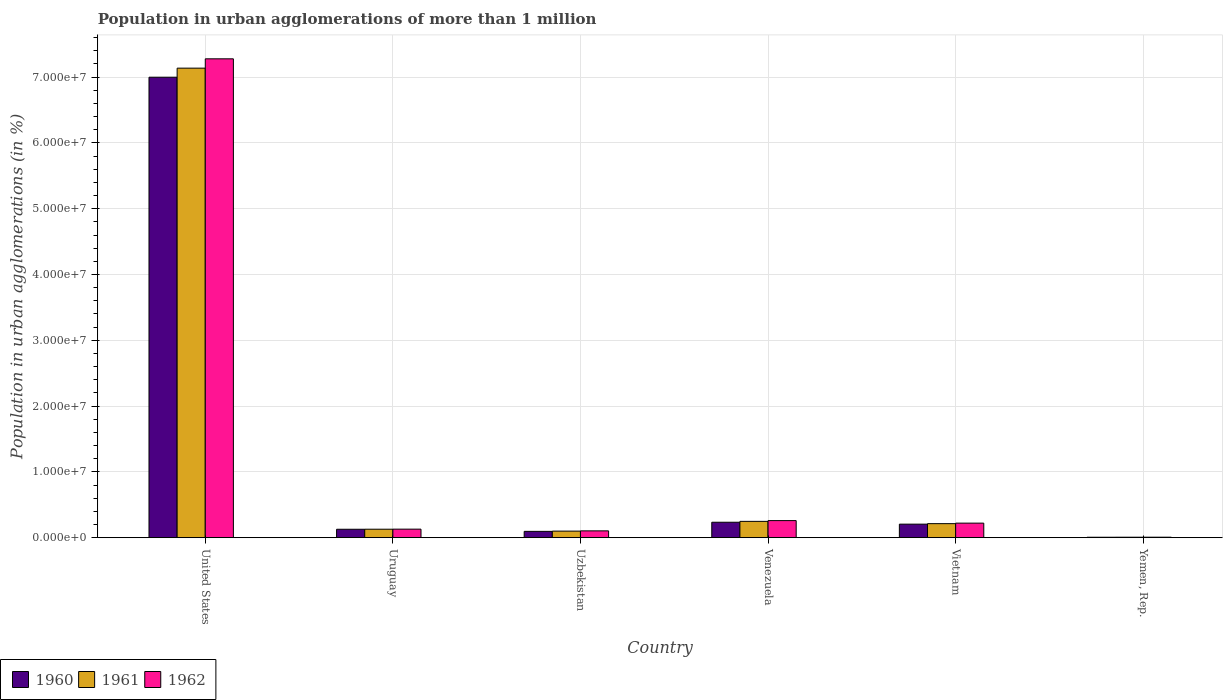Are the number of bars per tick equal to the number of legend labels?
Provide a succinct answer. Yes. How many bars are there on the 1st tick from the left?
Offer a very short reply. 3. What is the label of the 6th group of bars from the left?
Provide a short and direct response. Yemen, Rep. What is the population in urban agglomerations in 1961 in Uzbekistan?
Your response must be concise. 1.00e+06. Across all countries, what is the maximum population in urban agglomerations in 1962?
Make the answer very short. 7.28e+07. Across all countries, what is the minimum population in urban agglomerations in 1960?
Provide a short and direct response. 7.20e+04. In which country was the population in urban agglomerations in 1960 minimum?
Keep it short and to the point. Yemen, Rep. What is the total population in urban agglomerations in 1960 in the graph?
Your answer should be very brief. 7.67e+07. What is the difference between the population in urban agglomerations in 1960 in United States and that in Uzbekistan?
Offer a very short reply. 6.90e+07. What is the difference between the population in urban agglomerations in 1962 in Venezuela and the population in urban agglomerations in 1961 in United States?
Your response must be concise. -6.88e+07. What is the average population in urban agglomerations in 1960 per country?
Keep it short and to the point. 1.28e+07. What is the difference between the population in urban agglomerations of/in 1960 and population in urban agglomerations of/in 1961 in Uzbekistan?
Give a very brief answer. -3.73e+04. In how many countries, is the population in urban agglomerations in 1960 greater than 8000000 %?
Make the answer very short. 1. What is the ratio of the population in urban agglomerations in 1961 in United States to that in Venezuela?
Provide a succinct answer. 28.73. What is the difference between the highest and the second highest population in urban agglomerations in 1962?
Ensure brevity in your answer.  7.02e+07. What is the difference between the highest and the lowest population in urban agglomerations in 1961?
Your response must be concise. 7.13e+07. Is the sum of the population in urban agglomerations in 1962 in Uzbekistan and Vietnam greater than the maximum population in urban agglomerations in 1960 across all countries?
Provide a short and direct response. No. What does the 3rd bar from the left in Yemen, Rep. represents?
Ensure brevity in your answer.  1962. Is it the case that in every country, the sum of the population in urban agglomerations in 1962 and population in urban agglomerations in 1961 is greater than the population in urban agglomerations in 1960?
Ensure brevity in your answer.  Yes. How many countries are there in the graph?
Offer a terse response. 6. Are the values on the major ticks of Y-axis written in scientific E-notation?
Ensure brevity in your answer.  Yes. Does the graph contain grids?
Offer a very short reply. Yes. Where does the legend appear in the graph?
Offer a terse response. Bottom left. How many legend labels are there?
Ensure brevity in your answer.  3. What is the title of the graph?
Offer a terse response. Population in urban agglomerations of more than 1 million. What is the label or title of the Y-axis?
Provide a succinct answer. Population in urban agglomerations (in %). What is the Population in urban agglomerations (in %) of 1960 in United States?
Give a very brief answer. 7.00e+07. What is the Population in urban agglomerations (in %) of 1961 in United States?
Your answer should be compact. 7.14e+07. What is the Population in urban agglomerations (in %) of 1962 in United States?
Your answer should be compact. 7.28e+07. What is the Population in urban agglomerations (in %) of 1960 in Uruguay?
Give a very brief answer. 1.28e+06. What is the Population in urban agglomerations (in %) of 1961 in Uruguay?
Your answer should be very brief. 1.29e+06. What is the Population in urban agglomerations (in %) in 1962 in Uruguay?
Make the answer very short. 1.30e+06. What is the Population in urban agglomerations (in %) in 1960 in Uzbekistan?
Offer a very short reply. 9.64e+05. What is the Population in urban agglomerations (in %) in 1961 in Uzbekistan?
Your answer should be compact. 1.00e+06. What is the Population in urban agglomerations (in %) of 1962 in Uzbekistan?
Give a very brief answer. 1.04e+06. What is the Population in urban agglomerations (in %) in 1960 in Venezuela?
Make the answer very short. 2.35e+06. What is the Population in urban agglomerations (in %) in 1961 in Venezuela?
Make the answer very short. 2.48e+06. What is the Population in urban agglomerations (in %) in 1962 in Venezuela?
Make the answer very short. 2.60e+06. What is the Population in urban agglomerations (in %) in 1960 in Vietnam?
Give a very brief answer. 2.06e+06. What is the Population in urban agglomerations (in %) of 1961 in Vietnam?
Provide a succinct answer. 2.14e+06. What is the Population in urban agglomerations (in %) in 1962 in Vietnam?
Your answer should be compact. 2.21e+06. What is the Population in urban agglomerations (in %) of 1960 in Yemen, Rep.?
Ensure brevity in your answer.  7.20e+04. What is the Population in urban agglomerations (in %) in 1961 in Yemen, Rep.?
Your response must be concise. 7.52e+04. What is the Population in urban agglomerations (in %) of 1962 in Yemen, Rep.?
Provide a short and direct response. 7.84e+04. Across all countries, what is the maximum Population in urban agglomerations (in %) of 1960?
Make the answer very short. 7.00e+07. Across all countries, what is the maximum Population in urban agglomerations (in %) in 1961?
Ensure brevity in your answer.  7.14e+07. Across all countries, what is the maximum Population in urban agglomerations (in %) in 1962?
Provide a short and direct response. 7.28e+07. Across all countries, what is the minimum Population in urban agglomerations (in %) in 1960?
Provide a succinct answer. 7.20e+04. Across all countries, what is the minimum Population in urban agglomerations (in %) in 1961?
Your response must be concise. 7.52e+04. Across all countries, what is the minimum Population in urban agglomerations (in %) in 1962?
Give a very brief answer. 7.84e+04. What is the total Population in urban agglomerations (in %) in 1960 in the graph?
Your answer should be compact. 7.67e+07. What is the total Population in urban agglomerations (in %) of 1961 in the graph?
Your response must be concise. 7.83e+07. What is the total Population in urban agglomerations (in %) in 1962 in the graph?
Offer a very short reply. 8.00e+07. What is the difference between the Population in urban agglomerations (in %) of 1960 in United States and that in Uruguay?
Offer a terse response. 6.87e+07. What is the difference between the Population in urban agglomerations (in %) in 1961 in United States and that in Uruguay?
Give a very brief answer. 7.01e+07. What is the difference between the Population in urban agglomerations (in %) in 1962 in United States and that in Uruguay?
Provide a succinct answer. 7.15e+07. What is the difference between the Population in urban agglomerations (in %) in 1960 in United States and that in Uzbekistan?
Give a very brief answer. 6.90e+07. What is the difference between the Population in urban agglomerations (in %) in 1961 in United States and that in Uzbekistan?
Your answer should be compact. 7.04e+07. What is the difference between the Population in urban agglomerations (in %) of 1962 in United States and that in Uzbekistan?
Your answer should be very brief. 7.17e+07. What is the difference between the Population in urban agglomerations (in %) of 1960 in United States and that in Venezuela?
Provide a short and direct response. 6.76e+07. What is the difference between the Population in urban agglomerations (in %) in 1961 in United States and that in Venezuela?
Ensure brevity in your answer.  6.89e+07. What is the difference between the Population in urban agglomerations (in %) in 1962 in United States and that in Venezuela?
Give a very brief answer. 7.02e+07. What is the difference between the Population in urban agglomerations (in %) in 1960 in United States and that in Vietnam?
Keep it short and to the point. 6.79e+07. What is the difference between the Population in urban agglomerations (in %) in 1961 in United States and that in Vietnam?
Give a very brief answer. 6.92e+07. What is the difference between the Population in urban agglomerations (in %) of 1962 in United States and that in Vietnam?
Give a very brief answer. 7.06e+07. What is the difference between the Population in urban agglomerations (in %) of 1960 in United States and that in Yemen, Rep.?
Provide a succinct answer. 6.99e+07. What is the difference between the Population in urban agglomerations (in %) of 1961 in United States and that in Yemen, Rep.?
Keep it short and to the point. 7.13e+07. What is the difference between the Population in urban agglomerations (in %) of 1962 in United States and that in Yemen, Rep.?
Your answer should be very brief. 7.27e+07. What is the difference between the Population in urban agglomerations (in %) of 1960 in Uruguay and that in Uzbekistan?
Ensure brevity in your answer.  3.21e+05. What is the difference between the Population in urban agglomerations (in %) in 1961 in Uruguay and that in Uzbekistan?
Provide a short and direct response. 2.91e+05. What is the difference between the Population in urban agglomerations (in %) in 1962 in Uruguay and that in Uzbekistan?
Give a very brief answer. 2.60e+05. What is the difference between the Population in urban agglomerations (in %) in 1960 in Uruguay and that in Venezuela?
Give a very brief answer. -1.07e+06. What is the difference between the Population in urban agglomerations (in %) of 1961 in Uruguay and that in Venezuela?
Offer a terse response. -1.19e+06. What is the difference between the Population in urban agglomerations (in %) of 1962 in Uruguay and that in Venezuela?
Keep it short and to the point. -1.30e+06. What is the difference between the Population in urban agglomerations (in %) of 1960 in Uruguay and that in Vietnam?
Your response must be concise. -7.77e+05. What is the difference between the Population in urban agglomerations (in %) in 1961 in Uruguay and that in Vietnam?
Your response must be concise. -8.44e+05. What is the difference between the Population in urban agglomerations (in %) in 1962 in Uruguay and that in Vietnam?
Offer a very short reply. -9.14e+05. What is the difference between the Population in urban agglomerations (in %) of 1960 in Uruguay and that in Yemen, Rep.?
Make the answer very short. 1.21e+06. What is the difference between the Population in urban agglomerations (in %) of 1961 in Uruguay and that in Yemen, Rep.?
Your response must be concise. 1.22e+06. What is the difference between the Population in urban agglomerations (in %) in 1962 in Uruguay and that in Yemen, Rep.?
Ensure brevity in your answer.  1.22e+06. What is the difference between the Population in urban agglomerations (in %) of 1960 in Uzbekistan and that in Venezuela?
Give a very brief answer. -1.39e+06. What is the difference between the Population in urban agglomerations (in %) of 1961 in Uzbekistan and that in Venezuela?
Make the answer very short. -1.48e+06. What is the difference between the Population in urban agglomerations (in %) of 1962 in Uzbekistan and that in Venezuela?
Offer a very short reply. -1.56e+06. What is the difference between the Population in urban agglomerations (in %) of 1960 in Uzbekistan and that in Vietnam?
Ensure brevity in your answer.  -1.10e+06. What is the difference between the Population in urban agglomerations (in %) of 1961 in Uzbekistan and that in Vietnam?
Keep it short and to the point. -1.14e+06. What is the difference between the Population in urban agglomerations (in %) of 1962 in Uzbekistan and that in Vietnam?
Offer a very short reply. -1.17e+06. What is the difference between the Population in urban agglomerations (in %) in 1960 in Uzbekistan and that in Yemen, Rep.?
Your answer should be very brief. 8.92e+05. What is the difference between the Population in urban agglomerations (in %) of 1961 in Uzbekistan and that in Yemen, Rep.?
Offer a terse response. 9.26e+05. What is the difference between the Population in urban agglomerations (in %) of 1962 in Uzbekistan and that in Yemen, Rep.?
Provide a succinct answer. 9.61e+05. What is the difference between the Population in urban agglomerations (in %) of 1960 in Venezuela and that in Vietnam?
Offer a terse response. 2.88e+05. What is the difference between the Population in urban agglomerations (in %) in 1961 in Venezuela and that in Vietnam?
Ensure brevity in your answer.  3.47e+05. What is the difference between the Population in urban agglomerations (in %) in 1962 in Venezuela and that in Vietnam?
Your answer should be very brief. 3.86e+05. What is the difference between the Population in urban agglomerations (in %) in 1960 in Venezuela and that in Yemen, Rep.?
Keep it short and to the point. 2.28e+06. What is the difference between the Population in urban agglomerations (in %) in 1961 in Venezuela and that in Yemen, Rep.?
Your answer should be compact. 2.41e+06. What is the difference between the Population in urban agglomerations (in %) in 1962 in Venezuela and that in Yemen, Rep.?
Your response must be concise. 2.52e+06. What is the difference between the Population in urban agglomerations (in %) in 1960 in Vietnam and that in Yemen, Rep.?
Your answer should be very brief. 1.99e+06. What is the difference between the Population in urban agglomerations (in %) in 1961 in Vietnam and that in Yemen, Rep.?
Provide a short and direct response. 2.06e+06. What is the difference between the Population in urban agglomerations (in %) in 1962 in Vietnam and that in Yemen, Rep.?
Your answer should be compact. 2.14e+06. What is the difference between the Population in urban agglomerations (in %) in 1960 in United States and the Population in urban agglomerations (in %) in 1961 in Uruguay?
Offer a very short reply. 6.87e+07. What is the difference between the Population in urban agglomerations (in %) of 1960 in United States and the Population in urban agglomerations (in %) of 1962 in Uruguay?
Keep it short and to the point. 6.87e+07. What is the difference between the Population in urban agglomerations (in %) of 1961 in United States and the Population in urban agglomerations (in %) of 1962 in Uruguay?
Ensure brevity in your answer.  7.01e+07. What is the difference between the Population in urban agglomerations (in %) of 1960 in United States and the Population in urban agglomerations (in %) of 1961 in Uzbekistan?
Make the answer very short. 6.90e+07. What is the difference between the Population in urban agglomerations (in %) of 1960 in United States and the Population in urban agglomerations (in %) of 1962 in Uzbekistan?
Ensure brevity in your answer.  6.89e+07. What is the difference between the Population in urban agglomerations (in %) in 1961 in United States and the Population in urban agglomerations (in %) in 1962 in Uzbekistan?
Your response must be concise. 7.03e+07. What is the difference between the Population in urban agglomerations (in %) of 1960 in United States and the Population in urban agglomerations (in %) of 1961 in Venezuela?
Ensure brevity in your answer.  6.75e+07. What is the difference between the Population in urban agglomerations (in %) in 1960 in United States and the Population in urban agglomerations (in %) in 1962 in Venezuela?
Offer a terse response. 6.74e+07. What is the difference between the Population in urban agglomerations (in %) of 1961 in United States and the Population in urban agglomerations (in %) of 1962 in Venezuela?
Offer a very short reply. 6.88e+07. What is the difference between the Population in urban agglomerations (in %) of 1960 in United States and the Population in urban agglomerations (in %) of 1961 in Vietnam?
Ensure brevity in your answer.  6.78e+07. What is the difference between the Population in urban agglomerations (in %) of 1960 in United States and the Population in urban agglomerations (in %) of 1962 in Vietnam?
Your answer should be very brief. 6.78e+07. What is the difference between the Population in urban agglomerations (in %) in 1961 in United States and the Population in urban agglomerations (in %) in 1962 in Vietnam?
Your response must be concise. 6.91e+07. What is the difference between the Population in urban agglomerations (in %) in 1960 in United States and the Population in urban agglomerations (in %) in 1961 in Yemen, Rep.?
Provide a short and direct response. 6.99e+07. What is the difference between the Population in urban agglomerations (in %) in 1960 in United States and the Population in urban agglomerations (in %) in 1962 in Yemen, Rep.?
Provide a succinct answer. 6.99e+07. What is the difference between the Population in urban agglomerations (in %) in 1961 in United States and the Population in urban agglomerations (in %) in 1962 in Yemen, Rep.?
Offer a very short reply. 7.13e+07. What is the difference between the Population in urban agglomerations (in %) in 1960 in Uruguay and the Population in urban agglomerations (in %) in 1961 in Uzbekistan?
Offer a terse response. 2.84e+05. What is the difference between the Population in urban agglomerations (in %) of 1960 in Uruguay and the Population in urban agglomerations (in %) of 1962 in Uzbekistan?
Offer a very short reply. 2.45e+05. What is the difference between the Population in urban agglomerations (in %) of 1961 in Uruguay and the Population in urban agglomerations (in %) of 1962 in Uzbekistan?
Make the answer very short. 2.53e+05. What is the difference between the Population in urban agglomerations (in %) of 1960 in Uruguay and the Population in urban agglomerations (in %) of 1961 in Venezuela?
Offer a terse response. -1.20e+06. What is the difference between the Population in urban agglomerations (in %) of 1960 in Uruguay and the Population in urban agglomerations (in %) of 1962 in Venezuela?
Ensure brevity in your answer.  -1.31e+06. What is the difference between the Population in urban agglomerations (in %) in 1961 in Uruguay and the Population in urban agglomerations (in %) in 1962 in Venezuela?
Your answer should be very brief. -1.31e+06. What is the difference between the Population in urban agglomerations (in %) of 1960 in Uruguay and the Population in urban agglomerations (in %) of 1961 in Vietnam?
Your answer should be very brief. -8.52e+05. What is the difference between the Population in urban agglomerations (in %) in 1960 in Uruguay and the Population in urban agglomerations (in %) in 1962 in Vietnam?
Provide a succinct answer. -9.29e+05. What is the difference between the Population in urban agglomerations (in %) in 1961 in Uruguay and the Population in urban agglomerations (in %) in 1962 in Vietnam?
Provide a short and direct response. -9.22e+05. What is the difference between the Population in urban agglomerations (in %) of 1960 in Uruguay and the Population in urban agglomerations (in %) of 1961 in Yemen, Rep.?
Your answer should be compact. 1.21e+06. What is the difference between the Population in urban agglomerations (in %) in 1960 in Uruguay and the Population in urban agglomerations (in %) in 1962 in Yemen, Rep.?
Keep it short and to the point. 1.21e+06. What is the difference between the Population in urban agglomerations (in %) of 1961 in Uruguay and the Population in urban agglomerations (in %) of 1962 in Yemen, Rep.?
Your answer should be compact. 1.21e+06. What is the difference between the Population in urban agglomerations (in %) of 1960 in Uzbekistan and the Population in urban agglomerations (in %) of 1961 in Venezuela?
Offer a very short reply. -1.52e+06. What is the difference between the Population in urban agglomerations (in %) in 1960 in Uzbekistan and the Population in urban agglomerations (in %) in 1962 in Venezuela?
Provide a short and direct response. -1.64e+06. What is the difference between the Population in urban agglomerations (in %) of 1961 in Uzbekistan and the Population in urban agglomerations (in %) of 1962 in Venezuela?
Offer a terse response. -1.60e+06. What is the difference between the Population in urban agglomerations (in %) in 1960 in Uzbekistan and the Population in urban agglomerations (in %) in 1961 in Vietnam?
Ensure brevity in your answer.  -1.17e+06. What is the difference between the Population in urban agglomerations (in %) of 1960 in Uzbekistan and the Population in urban agglomerations (in %) of 1962 in Vietnam?
Make the answer very short. -1.25e+06. What is the difference between the Population in urban agglomerations (in %) of 1961 in Uzbekistan and the Population in urban agglomerations (in %) of 1962 in Vietnam?
Offer a terse response. -1.21e+06. What is the difference between the Population in urban agglomerations (in %) of 1960 in Uzbekistan and the Population in urban agglomerations (in %) of 1961 in Yemen, Rep.?
Ensure brevity in your answer.  8.89e+05. What is the difference between the Population in urban agglomerations (in %) of 1960 in Uzbekistan and the Population in urban agglomerations (in %) of 1962 in Yemen, Rep.?
Offer a terse response. 8.85e+05. What is the difference between the Population in urban agglomerations (in %) in 1961 in Uzbekistan and the Population in urban agglomerations (in %) in 1962 in Yemen, Rep.?
Give a very brief answer. 9.23e+05. What is the difference between the Population in urban agglomerations (in %) in 1960 in Venezuela and the Population in urban agglomerations (in %) in 1961 in Vietnam?
Offer a terse response. 2.13e+05. What is the difference between the Population in urban agglomerations (in %) of 1960 in Venezuela and the Population in urban agglomerations (in %) of 1962 in Vietnam?
Provide a succinct answer. 1.36e+05. What is the difference between the Population in urban agglomerations (in %) of 1961 in Venezuela and the Population in urban agglomerations (in %) of 1962 in Vietnam?
Keep it short and to the point. 2.69e+05. What is the difference between the Population in urban agglomerations (in %) in 1960 in Venezuela and the Population in urban agglomerations (in %) in 1961 in Yemen, Rep.?
Give a very brief answer. 2.27e+06. What is the difference between the Population in urban agglomerations (in %) in 1960 in Venezuela and the Population in urban agglomerations (in %) in 1962 in Yemen, Rep.?
Provide a succinct answer. 2.27e+06. What is the difference between the Population in urban agglomerations (in %) of 1961 in Venezuela and the Population in urban agglomerations (in %) of 1962 in Yemen, Rep.?
Make the answer very short. 2.40e+06. What is the difference between the Population in urban agglomerations (in %) of 1960 in Vietnam and the Population in urban agglomerations (in %) of 1961 in Yemen, Rep.?
Offer a terse response. 1.99e+06. What is the difference between the Population in urban agglomerations (in %) in 1960 in Vietnam and the Population in urban agglomerations (in %) in 1962 in Yemen, Rep.?
Offer a very short reply. 1.98e+06. What is the difference between the Population in urban agglomerations (in %) of 1961 in Vietnam and the Population in urban agglomerations (in %) of 1962 in Yemen, Rep.?
Offer a terse response. 2.06e+06. What is the average Population in urban agglomerations (in %) in 1960 per country?
Provide a succinct answer. 1.28e+07. What is the average Population in urban agglomerations (in %) of 1961 per country?
Keep it short and to the point. 1.31e+07. What is the average Population in urban agglomerations (in %) of 1962 per country?
Offer a very short reply. 1.33e+07. What is the difference between the Population in urban agglomerations (in %) in 1960 and Population in urban agglomerations (in %) in 1961 in United States?
Keep it short and to the point. -1.38e+06. What is the difference between the Population in urban agglomerations (in %) of 1960 and Population in urban agglomerations (in %) of 1962 in United States?
Your answer should be compact. -2.80e+06. What is the difference between the Population in urban agglomerations (in %) in 1961 and Population in urban agglomerations (in %) in 1962 in United States?
Provide a short and direct response. -1.42e+06. What is the difference between the Population in urban agglomerations (in %) of 1960 and Population in urban agglomerations (in %) of 1961 in Uruguay?
Ensure brevity in your answer.  -7522. What is the difference between the Population in urban agglomerations (in %) of 1960 and Population in urban agglomerations (in %) of 1962 in Uruguay?
Offer a very short reply. -1.51e+04. What is the difference between the Population in urban agglomerations (in %) in 1961 and Population in urban agglomerations (in %) in 1962 in Uruguay?
Give a very brief answer. -7578. What is the difference between the Population in urban agglomerations (in %) in 1960 and Population in urban agglomerations (in %) in 1961 in Uzbekistan?
Ensure brevity in your answer.  -3.73e+04. What is the difference between the Population in urban agglomerations (in %) of 1960 and Population in urban agglomerations (in %) of 1962 in Uzbekistan?
Provide a succinct answer. -7.60e+04. What is the difference between the Population in urban agglomerations (in %) of 1961 and Population in urban agglomerations (in %) of 1962 in Uzbekistan?
Your response must be concise. -3.88e+04. What is the difference between the Population in urban agglomerations (in %) in 1960 and Population in urban agglomerations (in %) in 1961 in Venezuela?
Offer a very short reply. -1.33e+05. What is the difference between the Population in urban agglomerations (in %) of 1960 and Population in urban agglomerations (in %) of 1962 in Venezuela?
Make the answer very short. -2.50e+05. What is the difference between the Population in urban agglomerations (in %) in 1961 and Population in urban agglomerations (in %) in 1962 in Venezuela?
Ensure brevity in your answer.  -1.16e+05. What is the difference between the Population in urban agglomerations (in %) in 1960 and Population in urban agglomerations (in %) in 1961 in Vietnam?
Keep it short and to the point. -7.48e+04. What is the difference between the Population in urban agglomerations (in %) of 1960 and Population in urban agglomerations (in %) of 1962 in Vietnam?
Provide a succinct answer. -1.52e+05. What is the difference between the Population in urban agglomerations (in %) of 1961 and Population in urban agglomerations (in %) of 1962 in Vietnam?
Your response must be concise. -7.76e+04. What is the difference between the Population in urban agglomerations (in %) of 1960 and Population in urban agglomerations (in %) of 1961 in Yemen, Rep.?
Provide a succinct answer. -3151. What is the difference between the Population in urban agglomerations (in %) of 1960 and Population in urban agglomerations (in %) of 1962 in Yemen, Rep.?
Make the answer very short. -6444. What is the difference between the Population in urban agglomerations (in %) in 1961 and Population in urban agglomerations (in %) in 1962 in Yemen, Rep.?
Ensure brevity in your answer.  -3293. What is the ratio of the Population in urban agglomerations (in %) in 1960 in United States to that in Uruguay?
Ensure brevity in your answer.  54.46. What is the ratio of the Population in urban agglomerations (in %) of 1961 in United States to that in Uruguay?
Give a very brief answer. 55.21. What is the ratio of the Population in urban agglomerations (in %) of 1962 in United States to that in Uruguay?
Offer a very short reply. 55.98. What is the ratio of the Population in urban agglomerations (in %) of 1960 in United States to that in Uzbekistan?
Make the answer very short. 72.6. What is the ratio of the Population in urban agglomerations (in %) in 1961 in United States to that in Uzbekistan?
Your answer should be very brief. 71.27. What is the ratio of the Population in urban agglomerations (in %) of 1962 in United States to that in Uzbekistan?
Provide a short and direct response. 69.98. What is the ratio of the Population in urban agglomerations (in %) of 1960 in United States to that in Venezuela?
Provide a succinct answer. 29.78. What is the ratio of the Population in urban agglomerations (in %) of 1961 in United States to that in Venezuela?
Provide a short and direct response. 28.73. What is the ratio of the Population in urban agglomerations (in %) in 1962 in United States to that in Venezuela?
Provide a succinct answer. 27.99. What is the ratio of the Population in urban agglomerations (in %) of 1960 in United States to that in Vietnam?
Your response must be concise. 33.94. What is the ratio of the Population in urban agglomerations (in %) in 1961 in United States to that in Vietnam?
Give a very brief answer. 33.4. What is the ratio of the Population in urban agglomerations (in %) in 1962 in United States to that in Vietnam?
Your answer should be compact. 32.87. What is the ratio of the Population in urban agglomerations (in %) of 1960 in United States to that in Yemen, Rep.?
Ensure brevity in your answer.  971.92. What is the ratio of the Population in urban agglomerations (in %) of 1961 in United States to that in Yemen, Rep.?
Your response must be concise. 949.52. What is the ratio of the Population in urban agglomerations (in %) of 1962 in United States to that in Yemen, Rep.?
Give a very brief answer. 927.73. What is the ratio of the Population in urban agglomerations (in %) of 1960 in Uruguay to that in Uzbekistan?
Offer a very short reply. 1.33. What is the ratio of the Population in urban agglomerations (in %) in 1961 in Uruguay to that in Uzbekistan?
Offer a very short reply. 1.29. What is the ratio of the Population in urban agglomerations (in %) of 1962 in Uruguay to that in Uzbekistan?
Your response must be concise. 1.25. What is the ratio of the Population in urban agglomerations (in %) of 1960 in Uruguay to that in Venezuela?
Your response must be concise. 0.55. What is the ratio of the Population in urban agglomerations (in %) in 1961 in Uruguay to that in Venezuela?
Your response must be concise. 0.52. What is the ratio of the Population in urban agglomerations (in %) of 1962 in Uruguay to that in Venezuela?
Provide a succinct answer. 0.5. What is the ratio of the Population in urban agglomerations (in %) of 1960 in Uruguay to that in Vietnam?
Your answer should be compact. 0.62. What is the ratio of the Population in urban agglomerations (in %) in 1961 in Uruguay to that in Vietnam?
Keep it short and to the point. 0.6. What is the ratio of the Population in urban agglomerations (in %) in 1962 in Uruguay to that in Vietnam?
Your answer should be compact. 0.59. What is the ratio of the Population in urban agglomerations (in %) of 1960 in Uruguay to that in Yemen, Rep.?
Your answer should be very brief. 17.85. What is the ratio of the Population in urban agglomerations (in %) of 1961 in Uruguay to that in Yemen, Rep.?
Offer a very short reply. 17.2. What is the ratio of the Population in urban agglomerations (in %) in 1962 in Uruguay to that in Yemen, Rep.?
Ensure brevity in your answer.  16.57. What is the ratio of the Population in urban agglomerations (in %) in 1960 in Uzbekistan to that in Venezuela?
Your answer should be compact. 0.41. What is the ratio of the Population in urban agglomerations (in %) in 1961 in Uzbekistan to that in Venezuela?
Offer a very short reply. 0.4. What is the ratio of the Population in urban agglomerations (in %) in 1960 in Uzbekistan to that in Vietnam?
Give a very brief answer. 0.47. What is the ratio of the Population in urban agglomerations (in %) of 1961 in Uzbekistan to that in Vietnam?
Your response must be concise. 0.47. What is the ratio of the Population in urban agglomerations (in %) of 1962 in Uzbekistan to that in Vietnam?
Your answer should be very brief. 0.47. What is the ratio of the Population in urban agglomerations (in %) of 1960 in Uzbekistan to that in Yemen, Rep.?
Make the answer very short. 13.39. What is the ratio of the Population in urban agglomerations (in %) in 1961 in Uzbekistan to that in Yemen, Rep.?
Your answer should be very brief. 13.32. What is the ratio of the Population in urban agglomerations (in %) in 1962 in Uzbekistan to that in Yemen, Rep.?
Make the answer very short. 13.26. What is the ratio of the Population in urban agglomerations (in %) in 1960 in Venezuela to that in Vietnam?
Provide a succinct answer. 1.14. What is the ratio of the Population in urban agglomerations (in %) in 1961 in Venezuela to that in Vietnam?
Provide a short and direct response. 1.16. What is the ratio of the Population in urban agglomerations (in %) of 1962 in Venezuela to that in Vietnam?
Ensure brevity in your answer.  1.17. What is the ratio of the Population in urban agglomerations (in %) of 1960 in Venezuela to that in Yemen, Rep.?
Ensure brevity in your answer.  32.64. What is the ratio of the Population in urban agglomerations (in %) of 1961 in Venezuela to that in Yemen, Rep.?
Your answer should be compact. 33.05. What is the ratio of the Population in urban agglomerations (in %) of 1962 in Venezuela to that in Yemen, Rep.?
Offer a terse response. 33.14. What is the ratio of the Population in urban agglomerations (in %) in 1960 in Vietnam to that in Yemen, Rep.?
Provide a short and direct response. 28.64. What is the ratio of the Population in urban agglomerations (in %) of 1961 in Vietnam to that in Yemen, Rep.?
Ensure brevity in your answer.  28.43. What is the ratio of the Population in urban agglomerations (in %) in 1962 in Vietnam to that in Yemen, Rep.?
Give a very brief answer. 28.23. What is the difference between the highest and the second highest Population in urban agglomerations (in %) of 1960?
Provide a short and direct response. 6.76e+07. What is the difference between the highest and the second highest Population in urban agglomerations (in %) of 1961?
Keep it short and to the point. 6.89e+07. What is the difference between the highest and the second highest Population in urban agglomerations (in %) of 1962?
Provide a short and direct response. 7.02e+07. What is the difference between the highest and the lowest Population in urban agglomerations (in %) of 1960?
Your response must be concise. 6.99e+07. What is the difference between the highest and the lowest Population in urban agglomerations (in %) of 1961?
Your answer should be very brief. 7.13e+07. What is the difference between the highest and the lowest Population in urban agglomerations (in %) of 1962?
Give a very brief answer. 7.27e+07. 